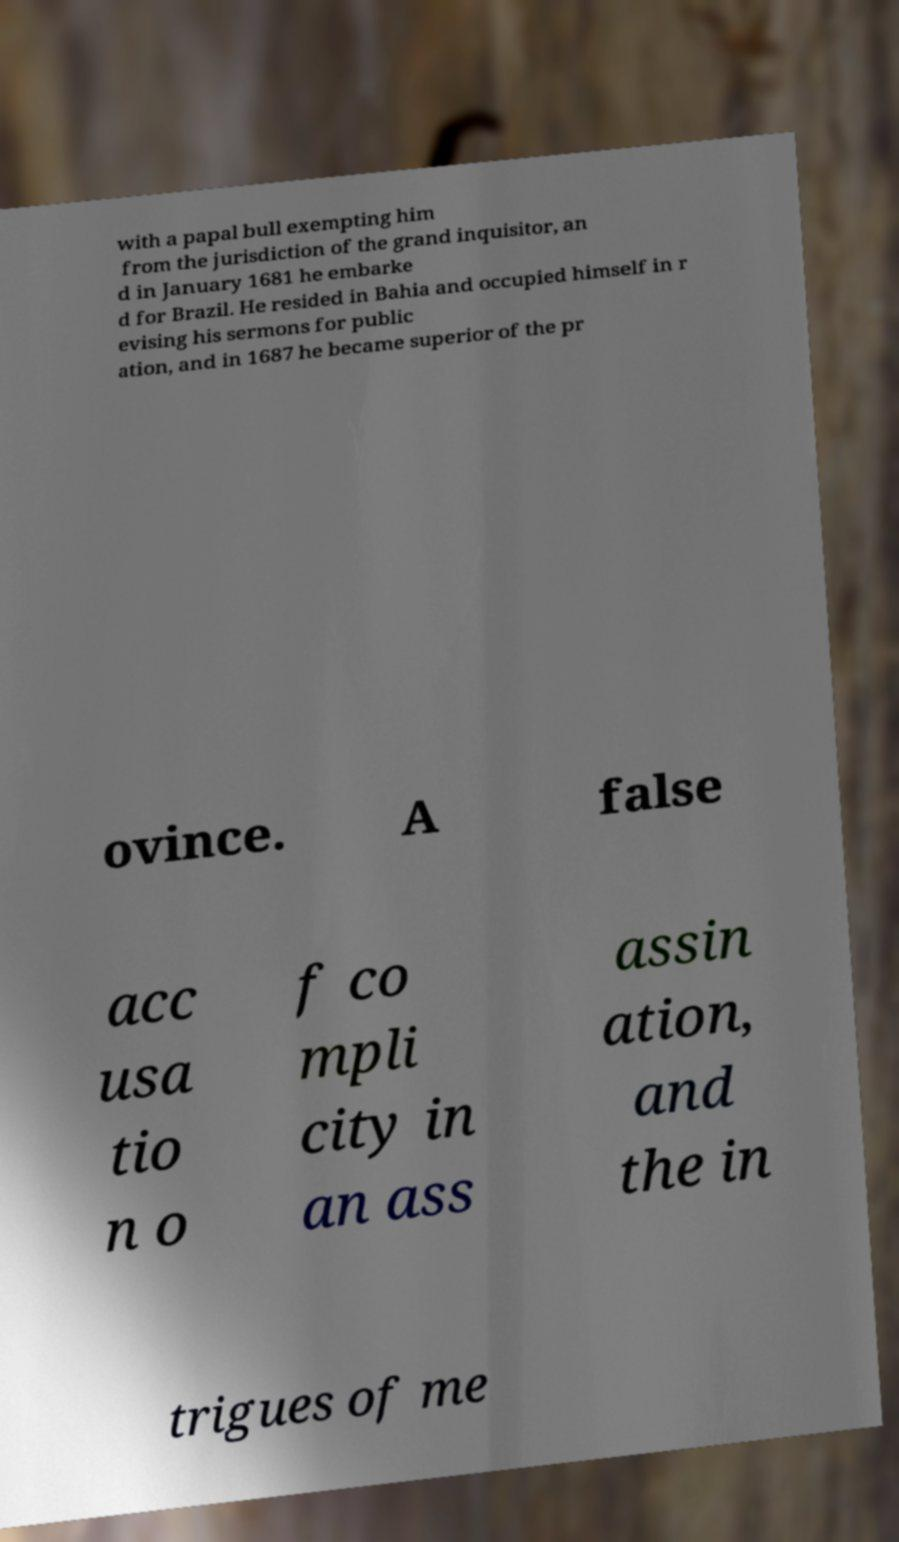For documentation purposes, I need the text within this image transcribed. Could you provide that? with a papal bull exempting him from the jurisdiction of the grand inquisitor, an d in January 1681 he embarke d for Brazil. He resided in Bahia and occupied himself in r evising his sermons for public ation, and in 1687 he became superior of the pr ovince. A false acc usa tio n o f co mpli city in an ass assin ation, and the in trigues of me 